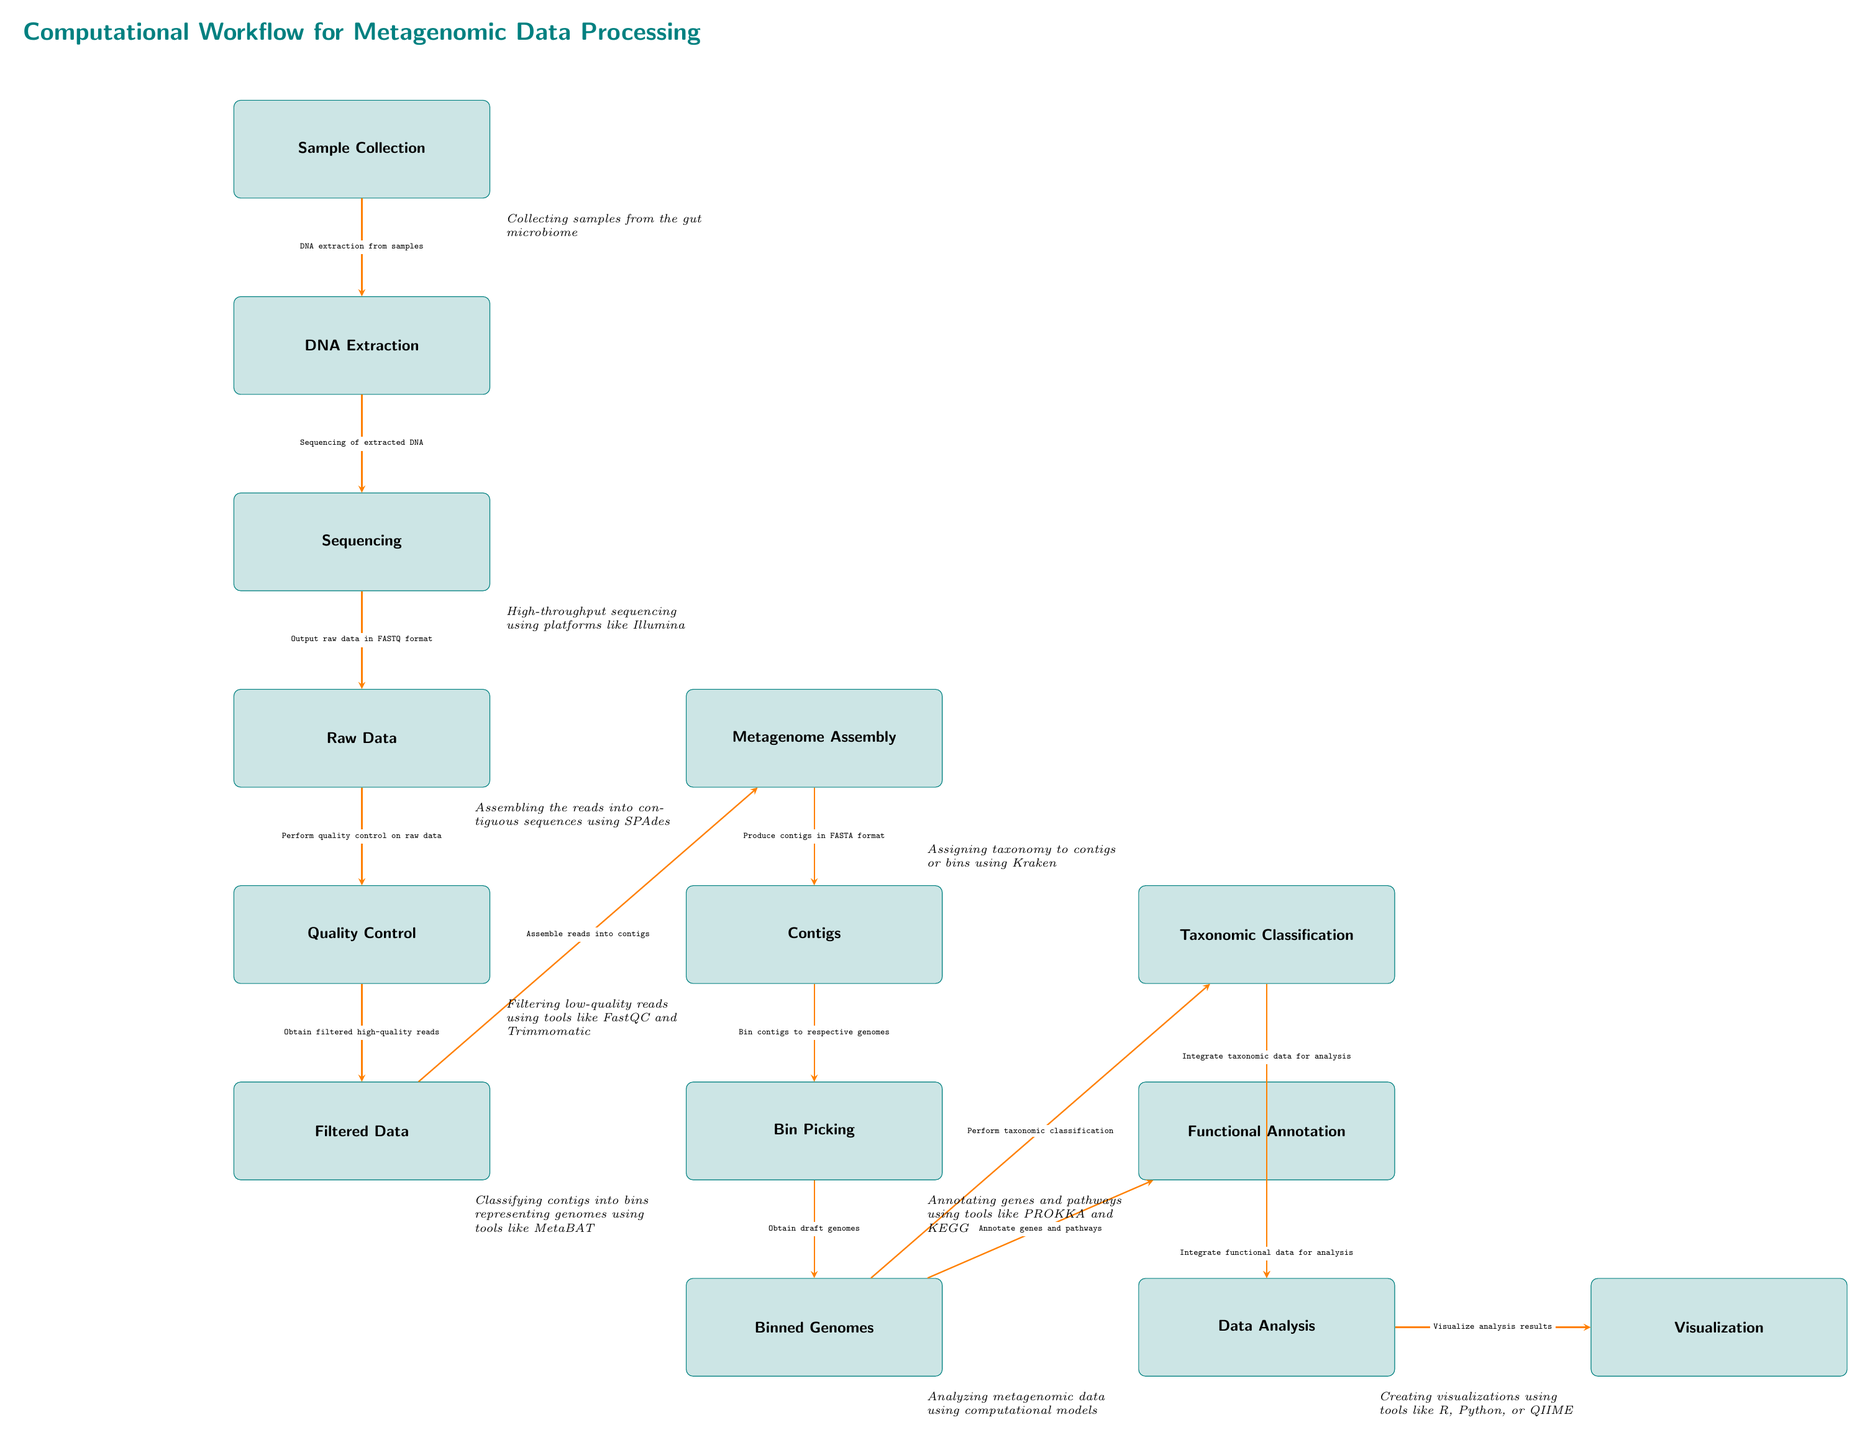What is the first step in the computational workflow? The first step, located at the top of the diagram, is "Sample Collection," which indicates the initial phase of the workflow.
Answer: Sample Collection How many nodes are in the diagram? Counting all distinct stages from "Sample Collection" to "Visualization," there are a total of 14 nodes in the workflow.
Answer: 14 What follows after the "Sequencing" step? The step immediately below "Sequencing" indicates that the next stage is "Raw Data," which is generated after sequencing the extracted DNA.
Answer: Raw Data Which tool is suggested for quality control? The annotations near the "Quality Control" box mention tools like FastQC and Trimmomatic for filtering low-quality reads.
Answer: FastQC and Trimmomatic How is the filtered data created? After the "Quality Control" step, which processes the raw data, the filtered high-quality reads are produced, representing the output of this quality control process.
Answer: Obtain filtered high-quality reads What are the two tasks performed after obtaining "Binned Genomes"? The two tasks are "Perform taxonomic classification" and "Annotate genes and pathways," both critical for analyzing the genomes binned from the contigs.
Answer: Perform taxonomic classification and annotate genes and pathways From "Contigs," what is the next step in the workflow? The diagram shows that after "Contigs," the next step is "Bin Picking," where contigs are classified into bins representing genomes.
Answer: Bin Picking What is the final output of the visualization process? The diagram indicates that the final output from the analysis workflow is the "Visualization" of analysis results.
Answer: Visualization Which stage involves integrating taxonomic and functional data for analysis? The stage titled "Data Analysis" is where both taxonomic and functional data are integrated for comprehensive analysis of the metagenomic data.
Answer: Data Analysis 